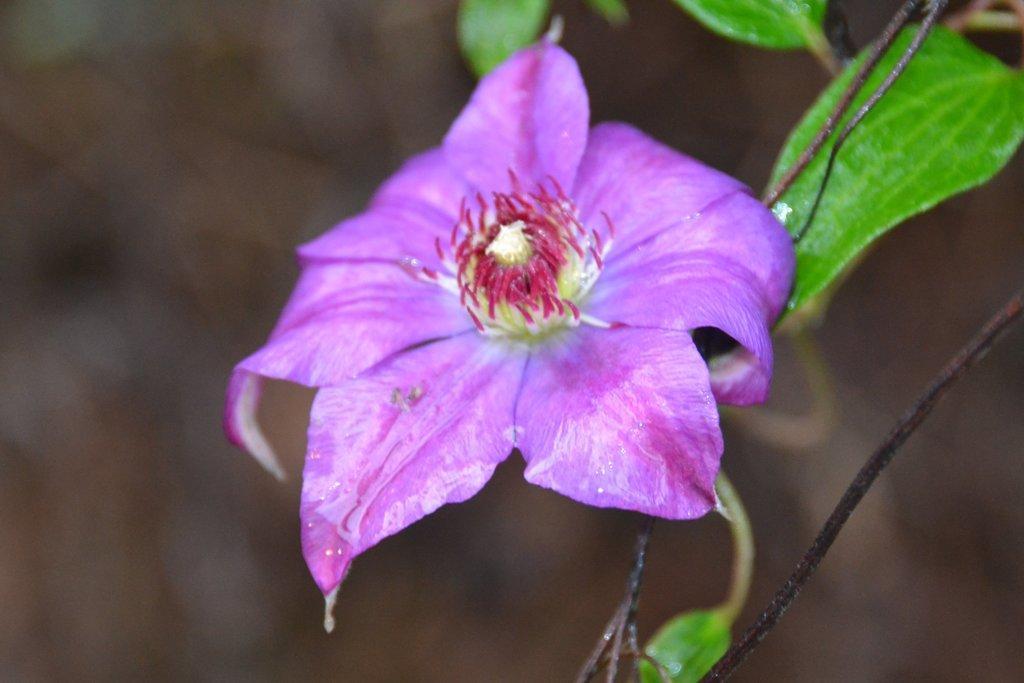In one or two sentences, can you explain what this image depicts? In this image I can see a purple color flower and I can see green leaves 